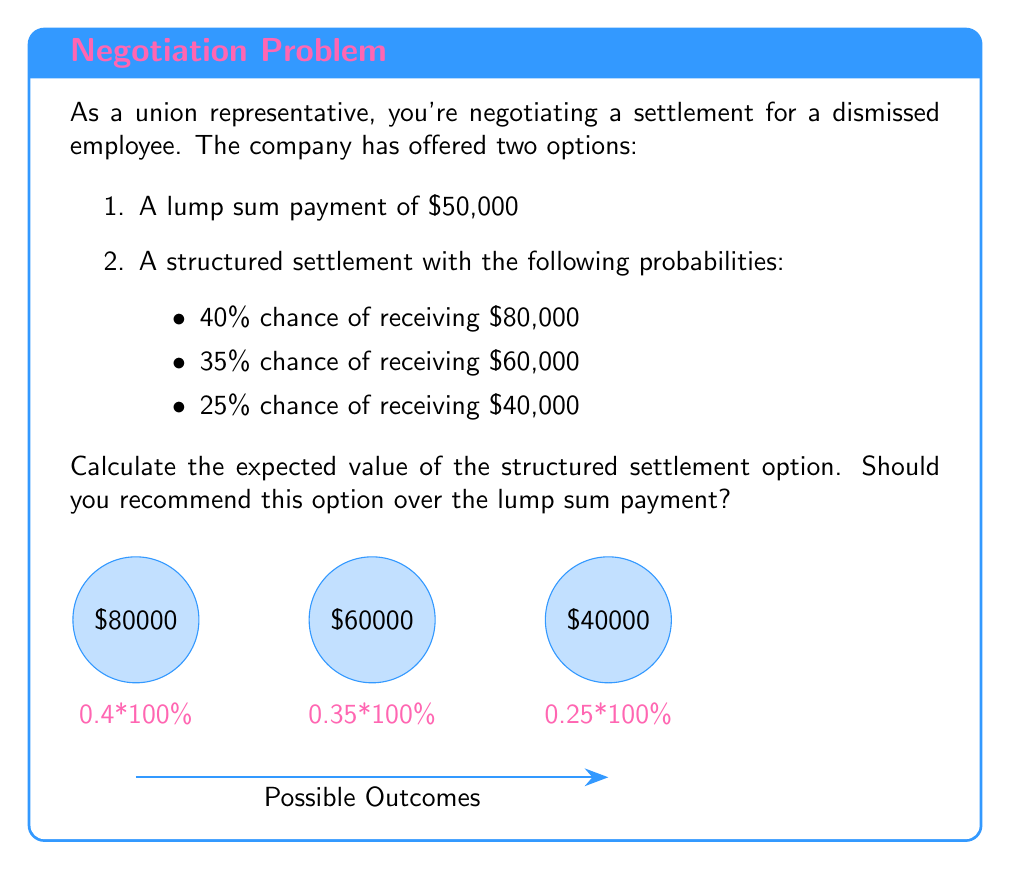Can you answer this question? To solve this problem, we need to calculate the expected value of the structured settlement option and compare it to the lump sum payment.

The expected value is calculated by multiplying each possible outcome by its probability and then summing these products.

Let's break it down step-by-step:

1) For the $80,000 outcome:
   Probability = 0.40
   $$ 80,000 \times 0.40 = 32,000 $$

2) For the $60,000 outcome:
   Probability = 0.35
   $$ 60,000 \times 0.35 = 21,000 $$

3) For the $40,000 outcome:
   Probability = 0.25
   $$ 40,000 \times 0.25 = 10,000 $$

4) Now, we sum these values:
   $$ 32,000 + 21,000 + 10,000 = 63,000 $$

Therefore, the expected value of the structured settlement is $63,000.

Comparing this to the lump sum payment of $50,000:
$$ 63,000 > 50,000 $$

The expected value of the structured settlement ($63,000) is higher than the lump sum payment ($50,000) by $13,000.
Answer: $63,000; recommend structured settlement 